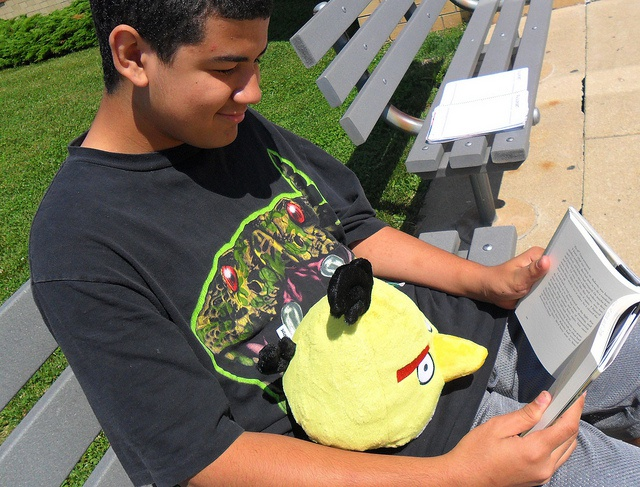Describe the objects in this image and their specific colors. I can see people in brown, black, salmon, and khaki tones, bench in brown, darkgray, white, black, and gray tones, bench in brown, gray, and darkgreen tones, book in brown, darkgray, lightgray, and gray tones, and book in brown, white, darkgray, and lightblue tones in this image. 